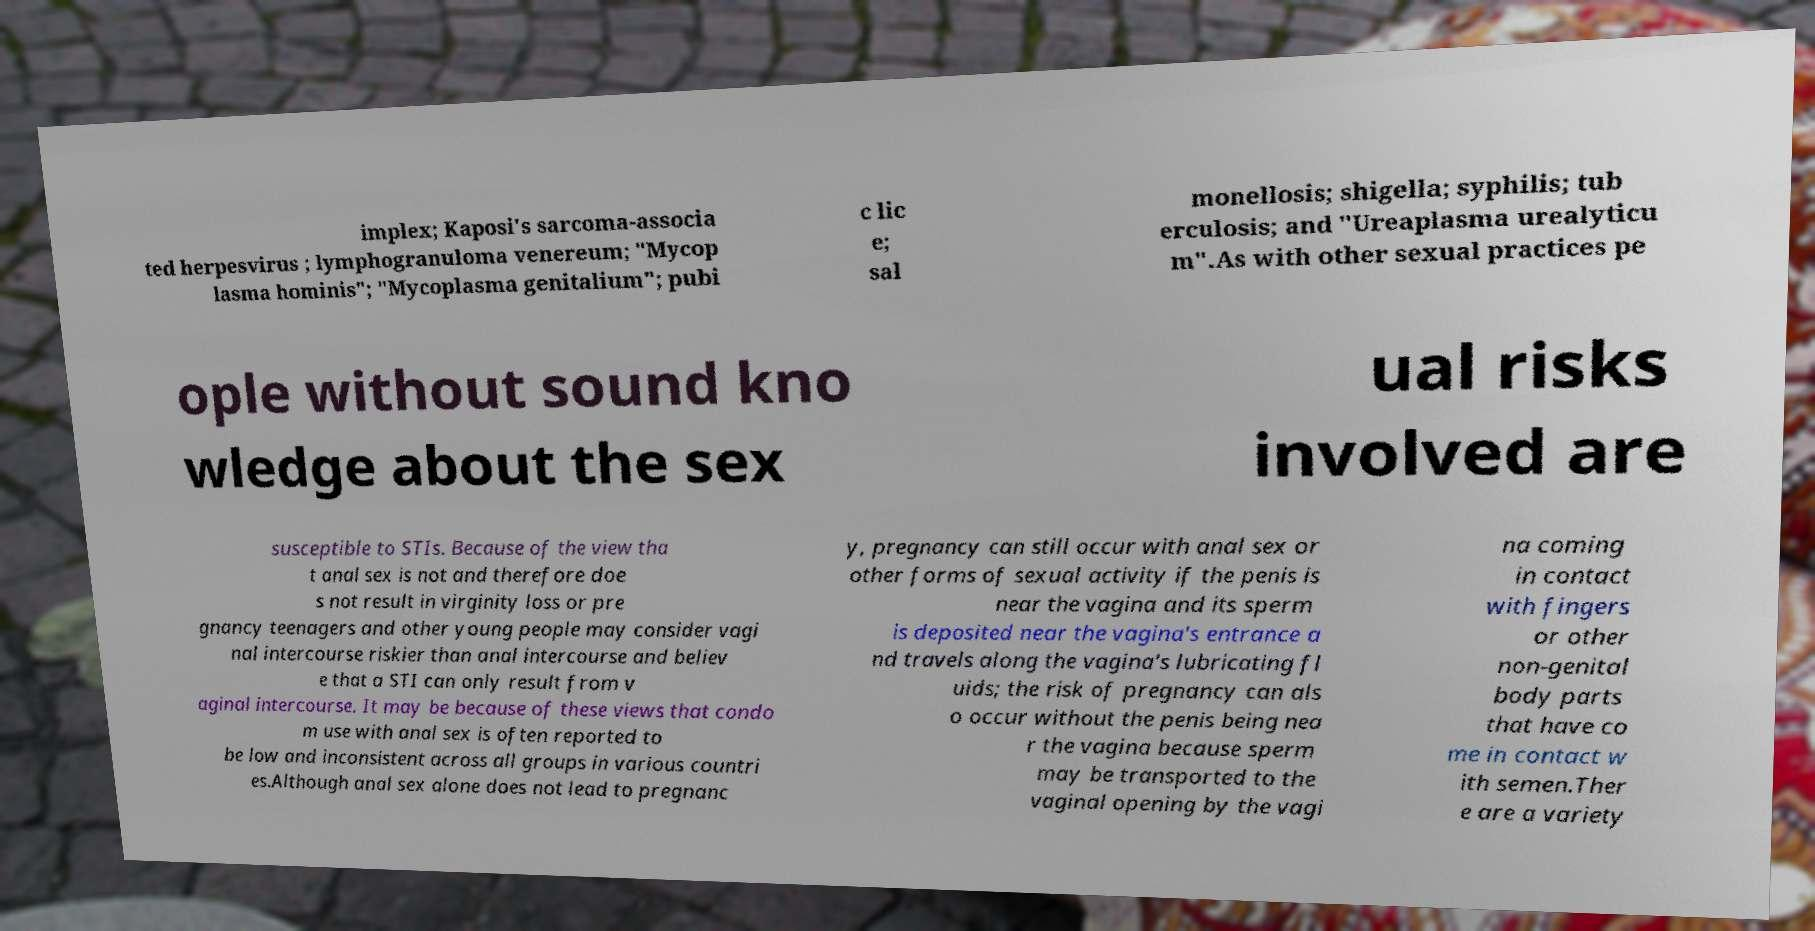There's text embedded in this image that I need extracted. Can you transcribe it verbatim? implex; Kaposi's sarcoma-associa ted herpesvirus ; lymphogranuloma venereum; "Mycop lasma hominis"; "Mycoplasma genitalium"; pubi c lic e; sal monellosis; shigella; syphilis; tub erculosis; and "Ureaplasma urealyticu m".As with other sexual practices pe ople without sound kno wledge about the sex ual risks involved are susceptible to STIs. Because of the view tha t anal sex is not and therefore doe s not result in virginity loss or pre gnancy teenagers and other young people may consider vagi nal intercourse riskier than anal intercourse and believ e that a STI can only result from v aginal intercourse. It may be because of these views that condo m use with anal sex is often reported to be low and inconsistent across all groups in various countri es.Although anal sex alone does not lead to pregnanc y, pregnancy can still occur with anal sex or other forms of sexual activity if the penis is near the vagina and its sperm is deposited near the vagina's entrance a nd travels along the vagina's lubricating fl uids; the risk of pregnancy can als o occur without the penis being nea r the vagina because sperm may be transported to the vaginal opening by the vagi na coming in contact with fingers or other non-genital body parts that have co me in contact w ith semen.Ther e are a variety 